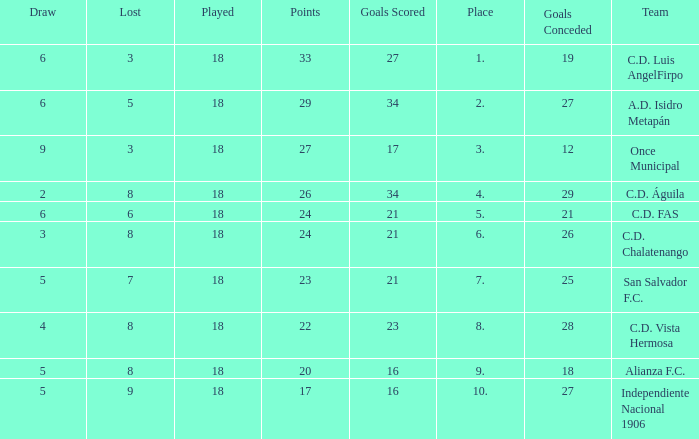How many points were in a game that had a lost of 5, greater than place 2, and 27 goals conceded? 0.0. 